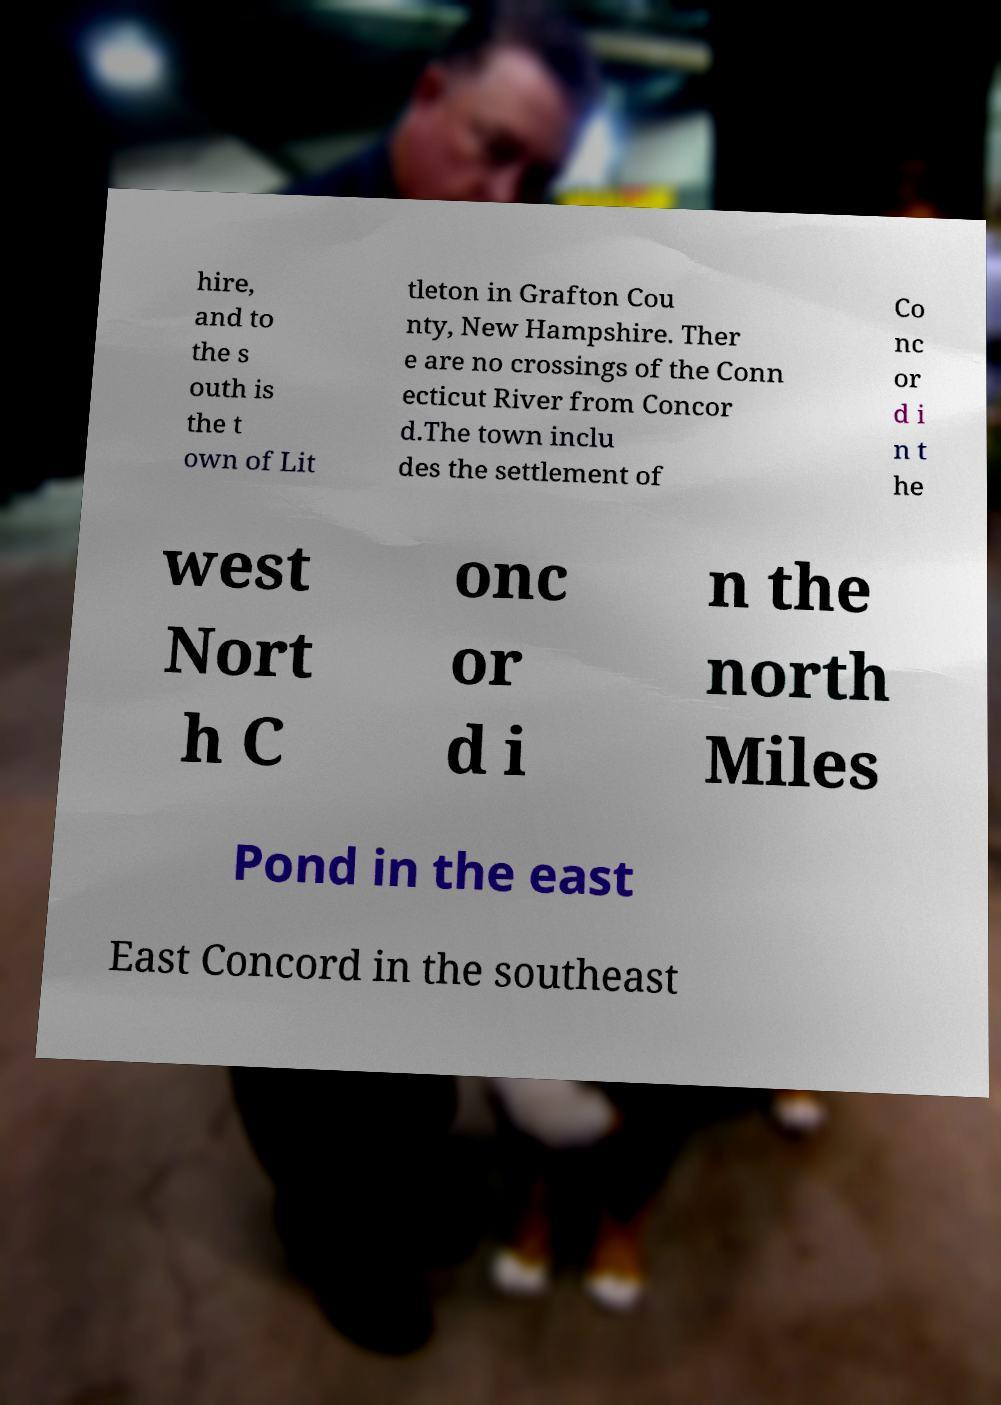Can you accurately transcribe the text from the provided image for me? hire, and to the s outh is the t own of Lit tleton in Grafton Cou nty, New Hampshire. Ther e are no crossings of the Conn ecticut River from Concor d.The town inclu des the settlement of Co nc or d i n t he west Nort h C onc or d i n the north Miles Pond in the east East Concord in the southeast 